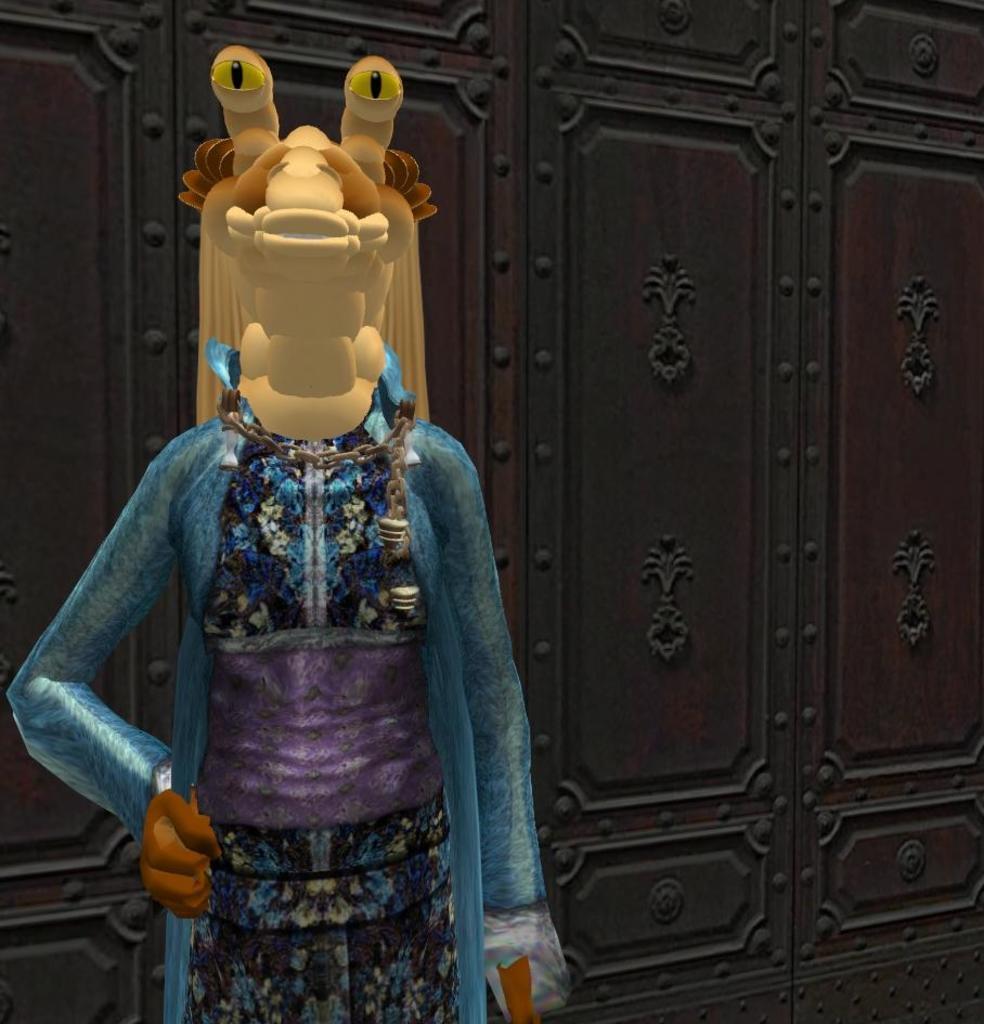Describe this image in one or two sentences. In this picture there is a toy doll on the left side of the image and there are cupboards in the background area of the image. 